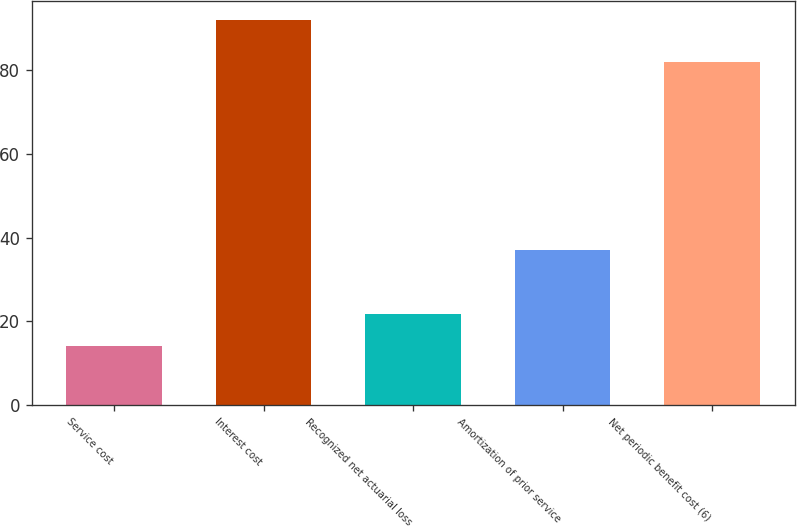Convert chart. <chart><loc_0><loc_0><loc_500><loc_500><bar_chart><fcel>Service cost<fcel>Interest cost<fcel>Recognized net actuarial loss<fcel>Amortization of prior service<fcel>Net periodic benefit cost (6)<nl><fcel>14<fcel>92<fcel>21.8<fcel>37<fcel>82<nl></chart> 